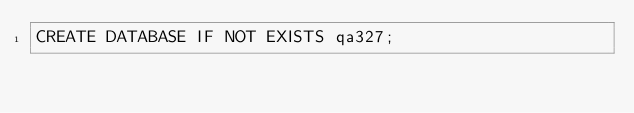Convert code to text. <code><loc_0><loc_0><loc_500><loc_500><_SQL_>CREATE DATABASE IF NOT EXISTS qa327; 
</code> 